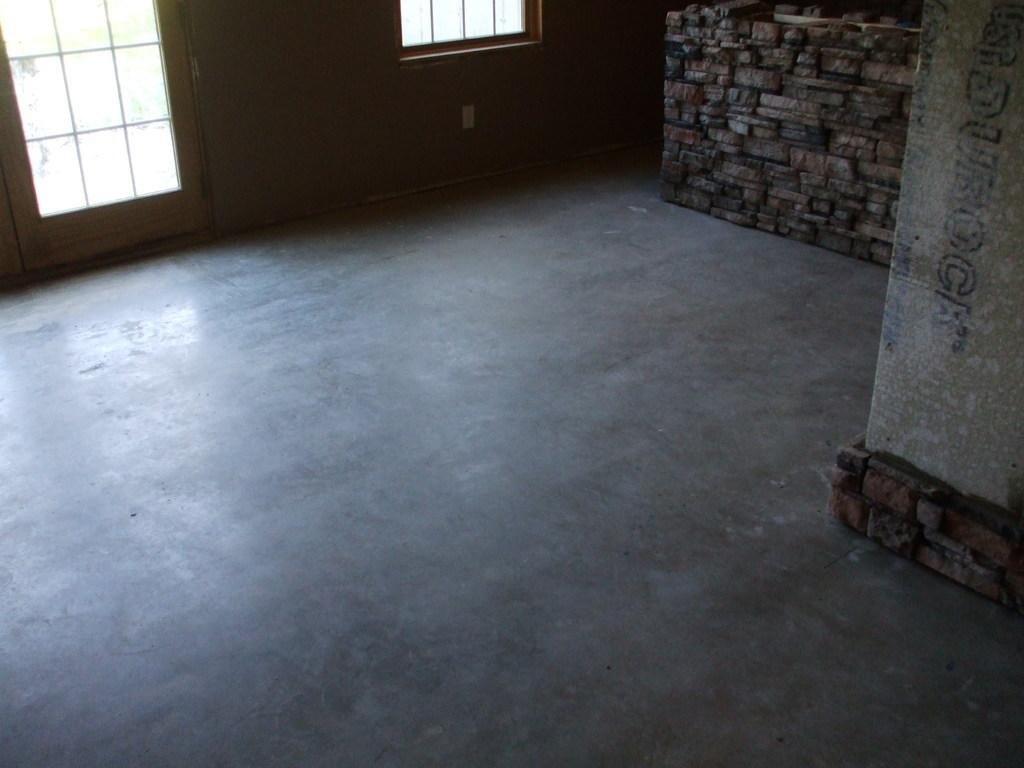What type of structure is visible at the top side of the image? There is a bricks wall at the top side of the image. What can be seen on the left side of the image? There are windows on the left side of the image. Can you tell me how many cacti are visible near the windows in the image? There is no cactus present in the image; it only features a bricks wall and windows. What type of event is taking place near the seashore in the image? There is no seashore or event present in the image; it only features a bricks wall and windows. 